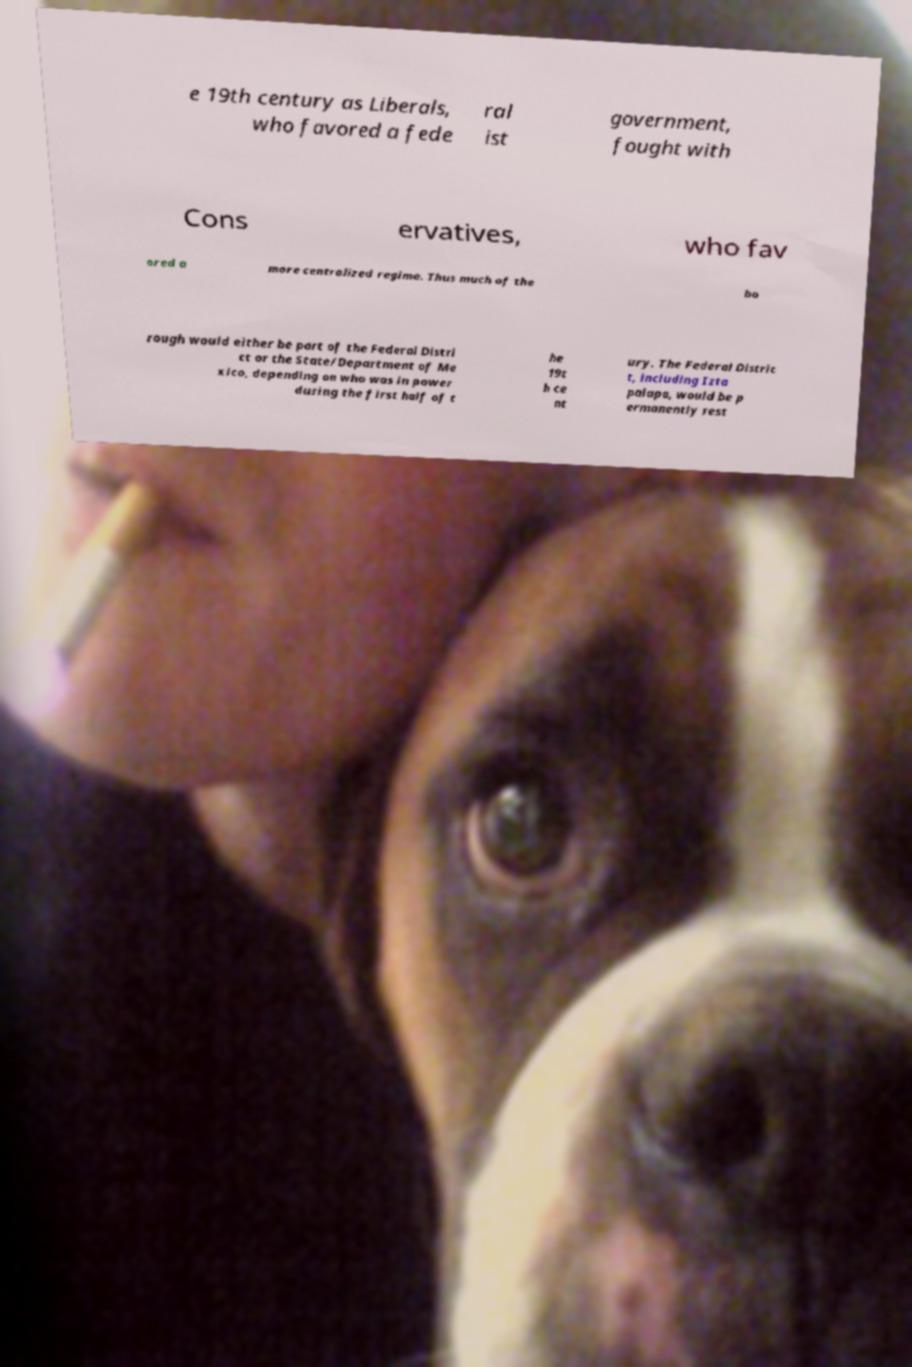I need the written content from this picture converted into text. Can you do that? e 19th century as Liberals, who favored a fede ral ist government, fought with Cons ervatives, who fav ored a more centralized regime. Thus much of the bo rough would either be part of the Federal Distri ct or the State/Department of Me xico, depending on who was in power during the first half of t he 19t h ce nt ury. The Federal Distric t, including Izta palapa, would be p ermanently rest 